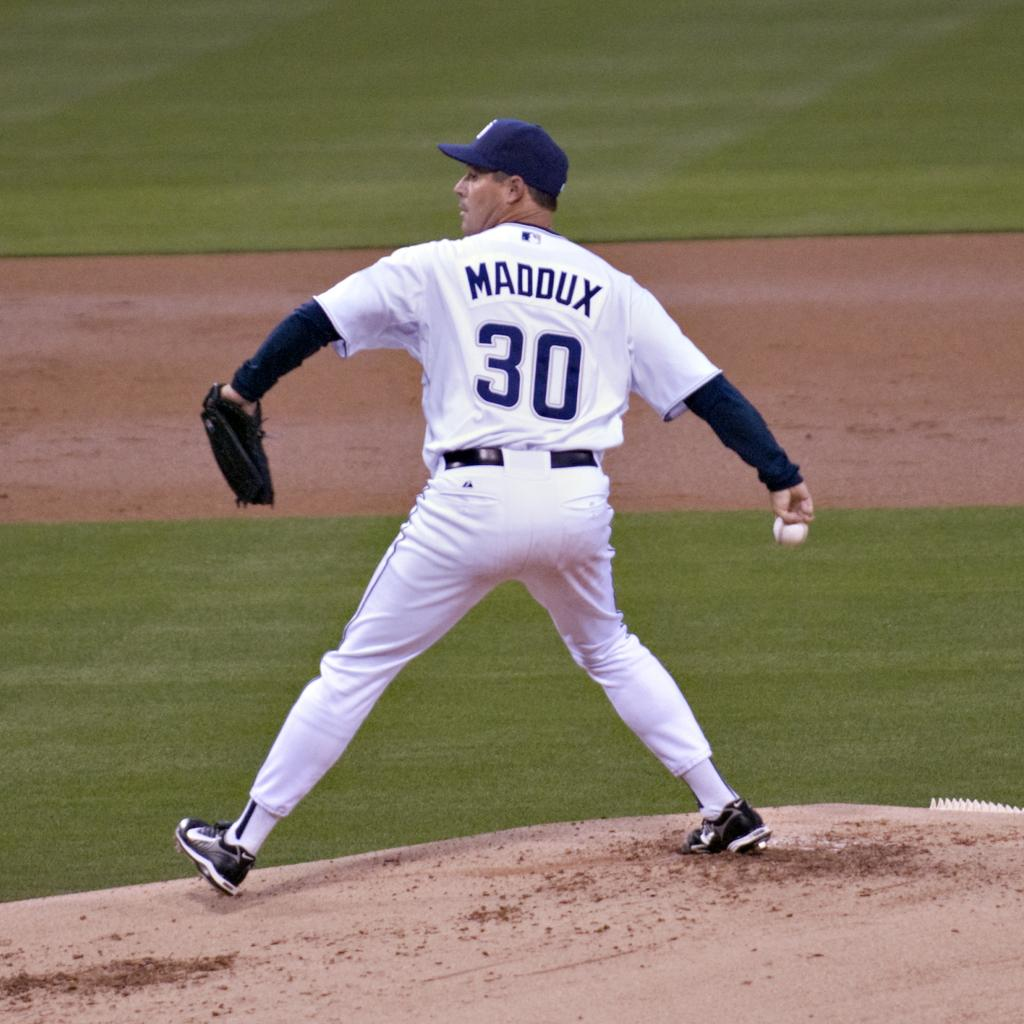<image>
Relay a brief, clear account of the picture shown. Maddux wearing number 30 is about to throw a pitch 